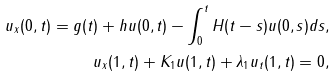<formula> <loc_0><loc_0><loc_500><loc_500>u _ { x } ( 0 , t ) = g ( t ) + h u ( 0 , t ) - \int _ { 0 } ^ { t } H ( t - s ) u ( 0 , s ) d s , \\ u _ { x } ( 1 , t ) + K _ { 1 } u ( 1 , t ) + \lambda _ { 1 } u _ { t } ( 1 , t ) = 0 ,</formula> 